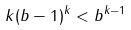Convert formula to latex. <formula><loc_0><loc_0><loc_500><loc_500>k ( b - 1 ) ^ { k } < b ^ { k - 1 }</formula> 